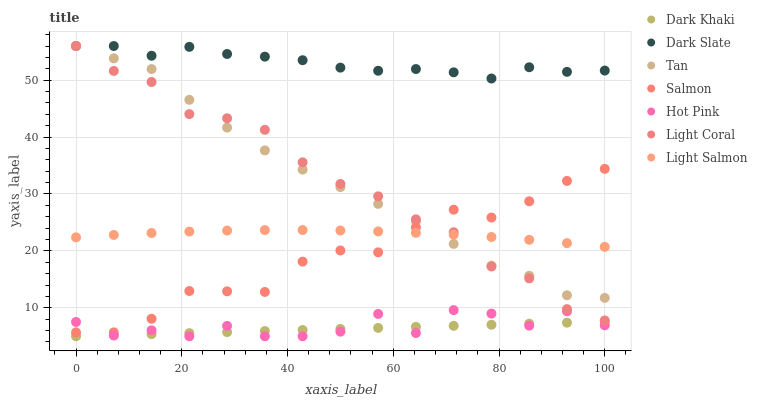Does Dark Khaki have the minimum area under the curve?
Answer yes or no. Yes. Does Dark Slate have the maximum area under the curve?
Answer yes or no. Yes. Does Light Salmon have the minimum area under the curve?
Answer yes or no. No. Does Light Salmon have the maximum area under the curve?
Answer yes or no. No. Is Dark Khaki the smoothest?
Answer yes or no. Yes. Is Hot Pink the roughest?
Answer yes or no. Yes. Is Light Salmon the smoothest?
Answer yes or no. No. Is Light Salmon the roughest?
Answer yes or no. No. Does Hot Pink have the lowest value?
Answer yes or no. Yes. Does Light Salmon have the lowest value?
Answer yes or no. No. Does Tan have the highest value?
Answer yes or no. Yes. Does Light Salmon have the highest value?
Answer yes or no. No. Is Dark Khaki less than Dark Slate?
Answer yes or no. Yes. Is Light Coral greater than Hot Pink?
Answer yes or no. Yes. Does Salmon intersect Hot Pink?
Answer yes or no. Yes. Is Salmon less than Hot Pink?
Answer yes or no. No. Is Salmon greater than Hot Pink?
Answer yes or no. No. Does Dark Khaki intersect Dark Slate?
Answer yes or no. No. 